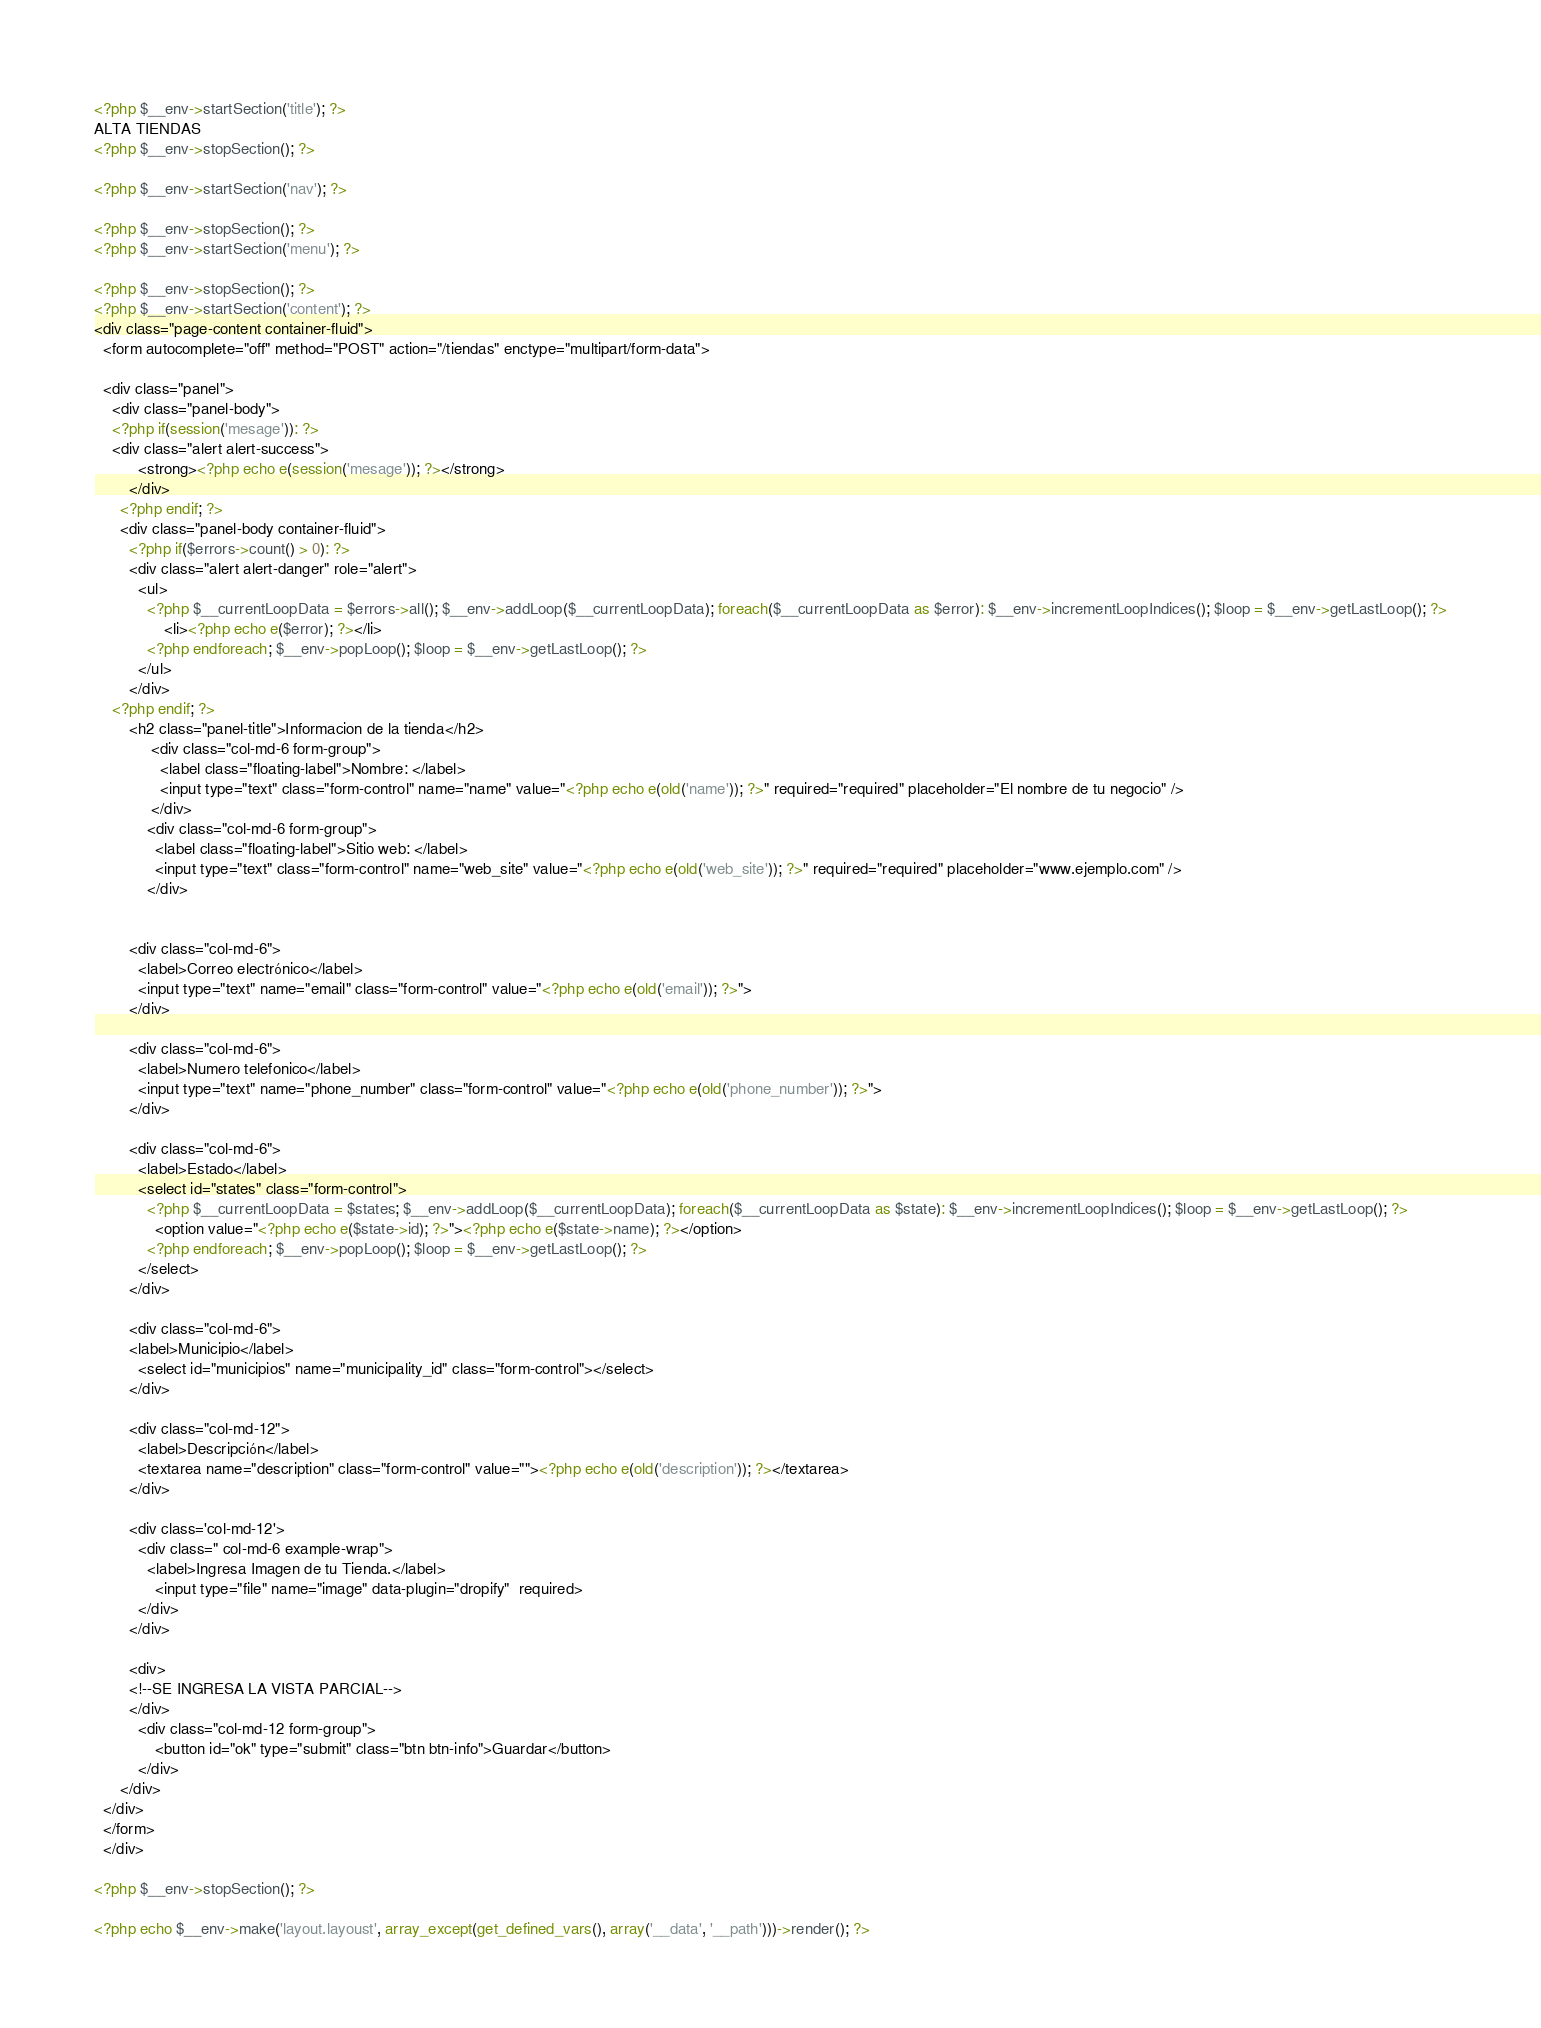Convert code to text. <code><loc_0><loc_0><loc_500><loc_500><_PHP_>
<?php $__env->startSection('title'); ?>
ALTA TIENDAS
<?php $__env->stopSection(); ?>

<?php $__env->startSection('nav'); ?>

<?php $__env->stopSection(); ?>
<?php $__env->startSection('menu'); ?>

<?php $__env->stopSection(); ?>
<?php $__env->startSection('content'); ?>
<div class="page-content container-fluid">
  <form autocomplete="off" method="POST" action="/tiendas" enctype="multipart/form-data">

  <div class="panel">
    <div class="panel-body">
    <?php if(session('mesage')): ?>
    <div class="alert alert-success">
          <strong><?php echo e(session('mesage')); ?></strong>
        </div>
      <?php endif; ?>
      <div class="panel-body container-fluid">
        <?php if($errors->count() > 0): ?>
        <div class="alert alert-danger" role="alert">
          <ul>
            <?php $__currentLoopData = $errors->all(); $__env->addLoop($__currentLoopData); foreach($__currentLoopData as $error): $__env->incrementLoopIndices(); $loop = $__env->getLastLoop(); ?>
                <li><?php echo e($error); ?></li>
            <?php endforeach; $__env->popLoop(); $loop = $__env->getLastLoop(); ?>
          </ul>
        </div>
    <?php endif; ?>
        <h2 class="panel-title">Informacion de la tienda</h2>
             <div class="col-md-6 form-group">
               <label class="floating-label">Nombre: </label>
               <input type="text" class="form-control" name="name" value="<?php echo e(old('name')); ?>" required="required" placeholder="El nombre de tu negocio" />
             </div>
            <div class="col-md-6 form-group">
              <label class="floating-label">Sitio web: </label>
              <input type="text" class="form-control" name="web_site" value="<?php echo e(old('web_site')); ?>" required="required" placeholder="www.ejemplo.com" />
            </div>


        <div class="col-md-6">
          <label>Correo electrónico</label>
          <input type="text" name="email" class="form-control" value="<?php echo e(old('email')); ?>">
        </div>

        <div class="col-md-6">
          <label>Numero telefonico</label>
          <input type="text" name="phone_number" class="form-control" value="<?php echo e(old('phone_number')); ?>">
        </div>

        <div class="col-md-6">
          <label>Estado</label>
          <select id="states" class="form-control">
            <?php $__currentLoopData = $states; $__env->addLoop($__currentLoopData); foreach($__currentLoopData as $state): $__env->incrementLoopIndices(); $loop = $__env->getLastLoop(); ?>
              <option value="<?php echo e($state->id); ?>"><?php echo e($state->name); ?></option>
            <?php endforeach; $__env->popLoop(); $loop = $__env->getLastLoop(); ?>
          </select>
        </div>

        <div class="col-md-6">
        <label>Municipio</label>
          <select id="municipios" name="municipality_id" class="form-control"></select>
        </div>

        <div class="col-md-12">
          <label>Descripción</label>
          <textarea name="description" class="form-control" value=""><?php echo e(old('description')); ?></textarea>
        </div>

        <div class='col-md-12'>
          <div class=" col-md-6 example-wrap">
            <label>Ingresa Imagen de tu Tienda.</label>
              <input type="file" name="image" data-plugin="dropify"  required>
          </div>
        </div>

        <div>
        <!--SE INGRESA LA VISTA PARCIAL-->
        </div>
          <div class="col-md-12 form-group">
              <button id="ok" type="submit" class="btn btn-info">Guardar</button>
          </div>
      </div>
  </div>
  </form>
  </div>

<?php $__env->stopSection(); ?>

<?php echo $__env->make('layout.layoust', array_except(get_defined_vars(), array('__data', '__path')))->render(); ?></code> 